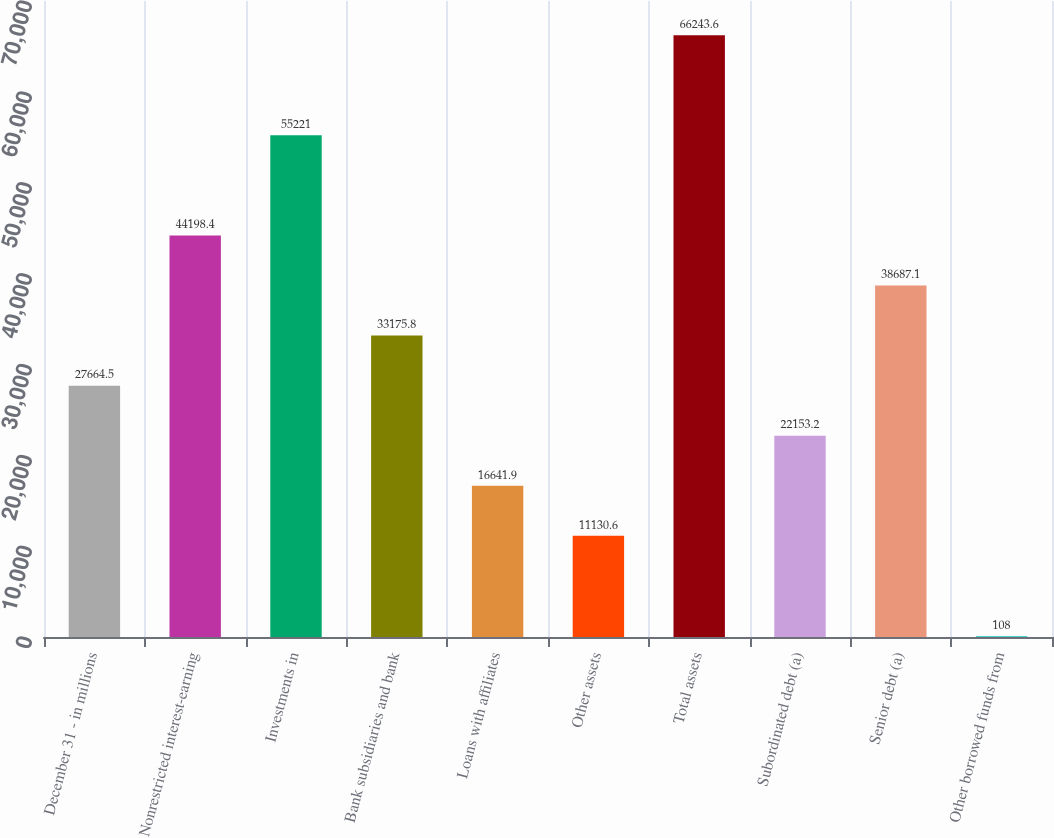Convert chart to OTSL. <chart><loc_0><loc_0><loc_500><loc_500><bar_chart><fcel>December 31 - in millions<fcel>Nonrestricted interest-earning<fcel>Investments in<fcel>Bank subsidiaries and bank<fcel>Loans with affiliates<fcel>Other assets<fcel>Total assets<fcel>Subordinated debt (a)<fcel>Senior debt (a)<fcel>Other borrowed funds from<nl><fcel>27664.5<fcel>44198.4<fcel>55221<fcel>33175.8<fcel>16641.9<fcel>11130.6<fcel>66243.6<fcel>22153.2<fcel>38687.1<fcel>108<nl></chart> 